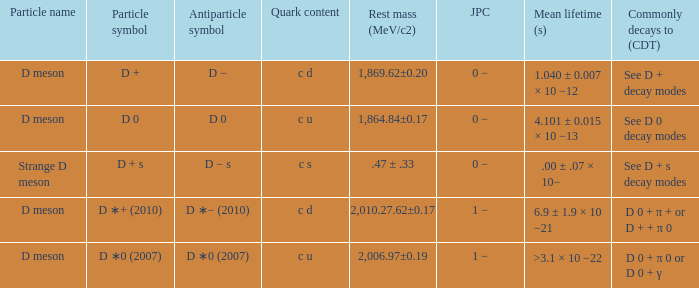What is the j p c that commonly decays (>5% of decays) d 0 + π 0 or d 0 + γ? 1 −. 